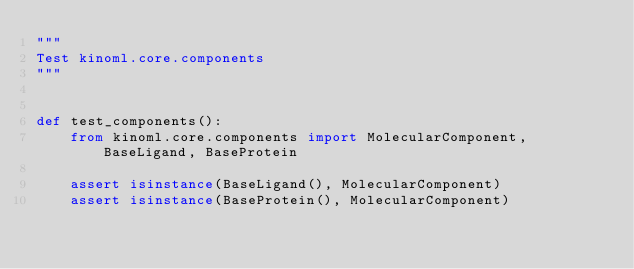<code> <loc_0><loc_0><loc_500><loc_500><_Python_>"""
Test kinoml.core.components
"""


def test_components():
    from kinoml.core.components import MolecularComponent, BaseLigand, BaseProtein

    assert isinstance(BaseLigand(), MolecularComponent)
    assert isinstance(BaseProtein(), MolecularComponent)
</code> 